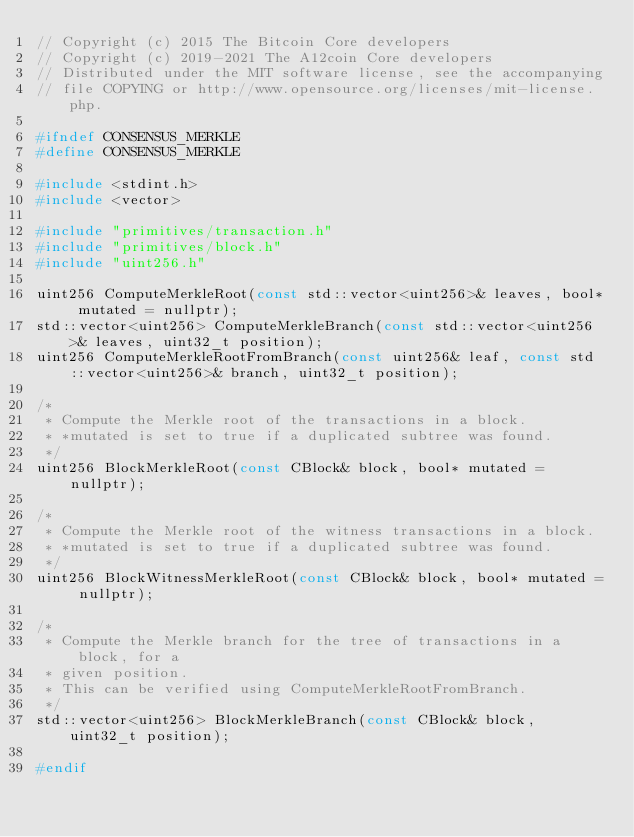Convert code to text. <code><loc_0><loc_0><loc_500><loc_500><_C_>// Copyright (c) 2015 The Bitcoin Core developers
// Copyright (c) 2019-2021 The A12coin Core developers
// Distributed under the MIT software license, see the accompanying
// file COPYING or http://www.opensource.org/licenses/mit-license.php.

#ifndef CONSENSUS_MERKLE
#define CONSENSUS_MERKLE

#include <stdint.h>
#include <vector>

#include "primitives/transaction.h"
#include "primitives/block.h"
#include "uint256.h"

uint256 ComputeMerkleRoot(const std::vector<uint256>& leaves, bool* mutated = nullptr);
std::vector<uint256> ComputeMerkleBranch(const std::vector<uint256>& leaves, uint32_t position);
uint256 ComputeMerkleRootFromBranch(const uint256& leaf, const std::vector<uint256>& branch, uint32_t position);

/*
 * Compute the Merkle root of the transactions in a block.
 * *mutated is set to true if a duplicated subtree was found.
 */
uint256 BlockMerkleRoot(const CBlock& block, bool* mutated = nullptr);

/*
 * Compute the Merkle root of the witness transactions in a block.
 * *mutated is set to true if a duplicated subtree was found.
 */
uint256 BlockWitnessMerkleRoot(const CBlock& block, bool* mutated = nullptr);

/*
 * Compute the Merkle branch for the tree of transactions in a block, for a
 * given position.
 * This can be verified using ComputeMerkleRootFromBranch.
 */
std::vector<uint256> BlockMerkleBranch(const CBlock& block, uint32_t position);

#endif
</code> 